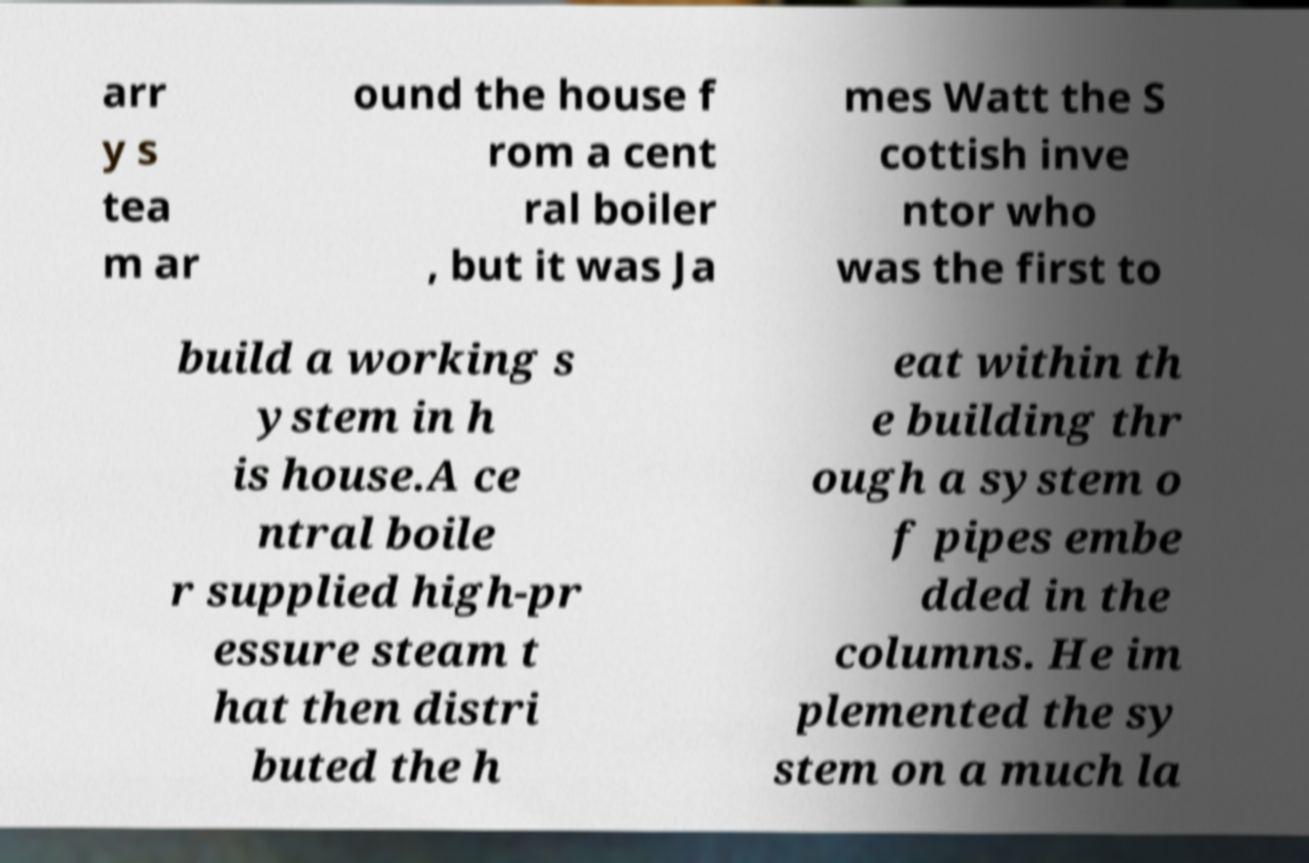Please identify and transcribe the text found in this image. arr y s tea m ar ound the house f rom a cent ral boiler , but it was Ja mes Watt the S cottish inve ntor who was the first to build a working s ystem in h is house.A ce ntral boile r supplied high-pr essure steam t hat then distri buted the h eat within th e building thr ough a system o f pipes embe dded in the columns. He im plemented the sy stem on a much la 